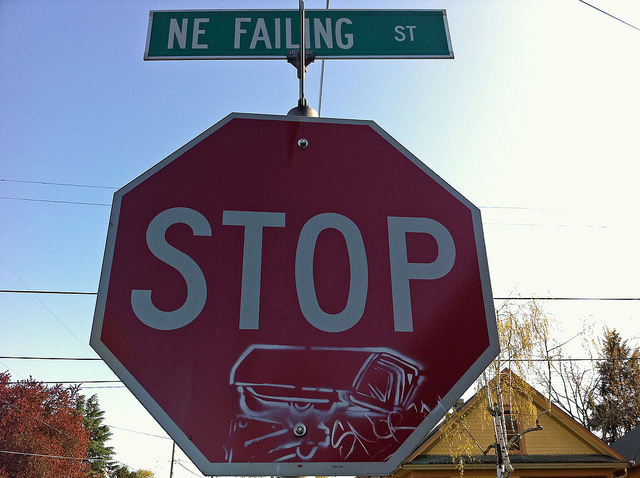Please transcribe the text in this image. NE FAILING ST STOP 